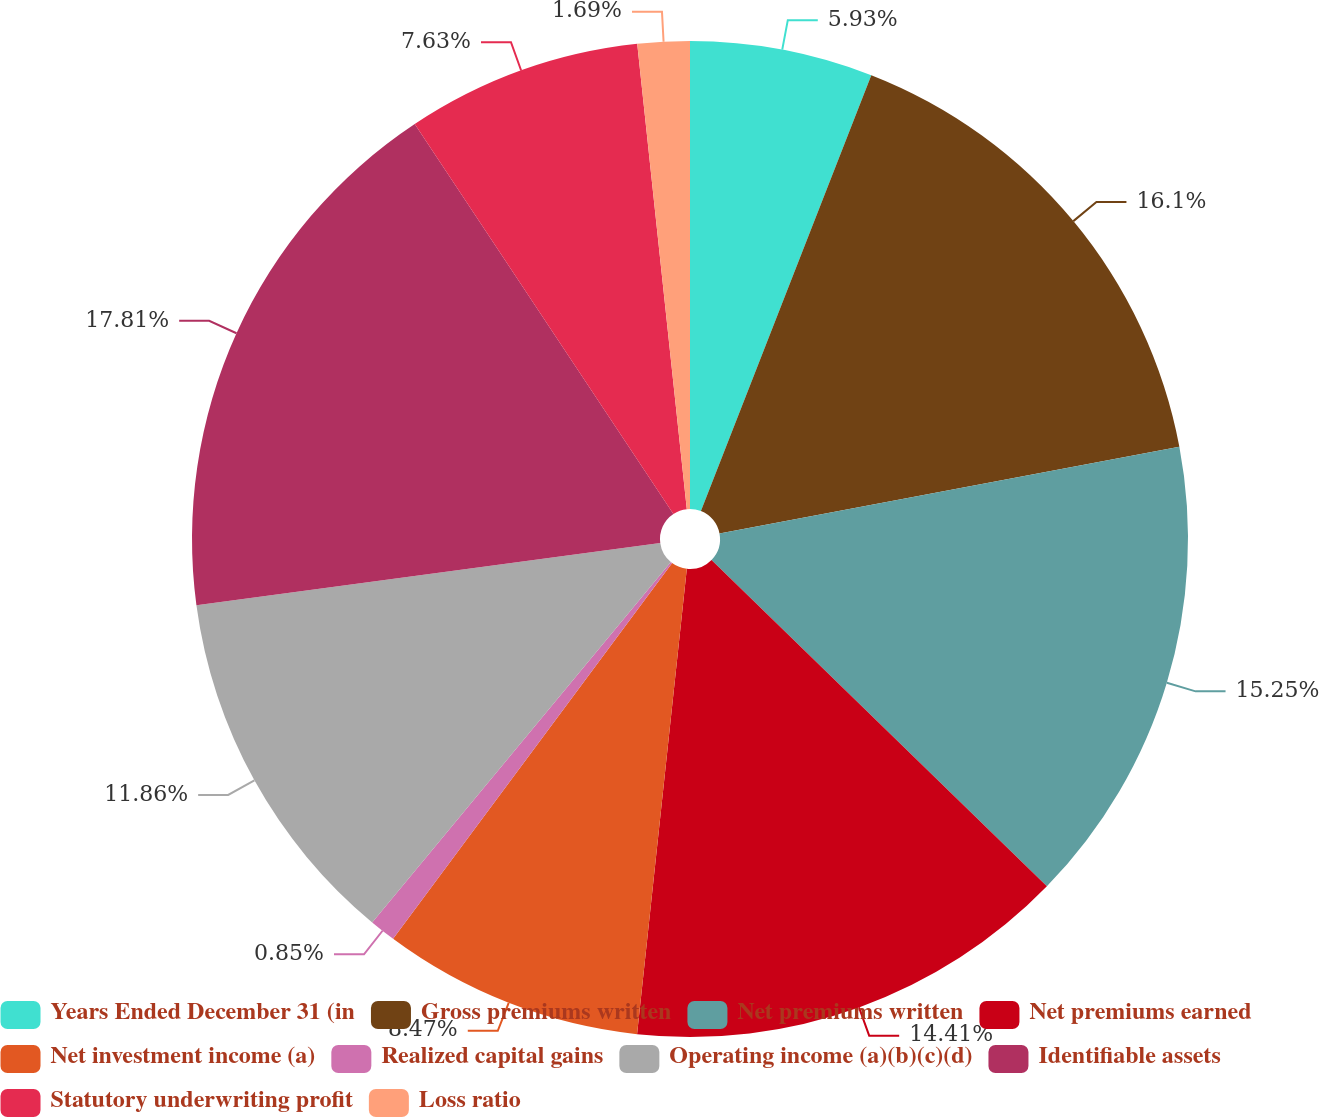Convert chart. <chart><loc_0><loc_0><loc_500><loc_500><pie_chart><fcel>Years Ended December 31 (in<fcel>Gross premiums written<fcel>Net premiums written<fcel>Net premiums earned<fcel>Net investment income (a)<fcel>Realized capital gains<fcel>Operating income (a)(b)(c)(d)<fcel>Identifiable assets<fcel>Statutory underwriting profit<fcel>Loss ratio<nl><fcel>5.93%<fcel>16.1%<fcel>15.25%<fcel>14.41%<fcel>8.47%<fcel>0.85%<fcel>11.86%<fcel>17.8%<fcel>7.63%<fcel>1.69%<nl></chart> 